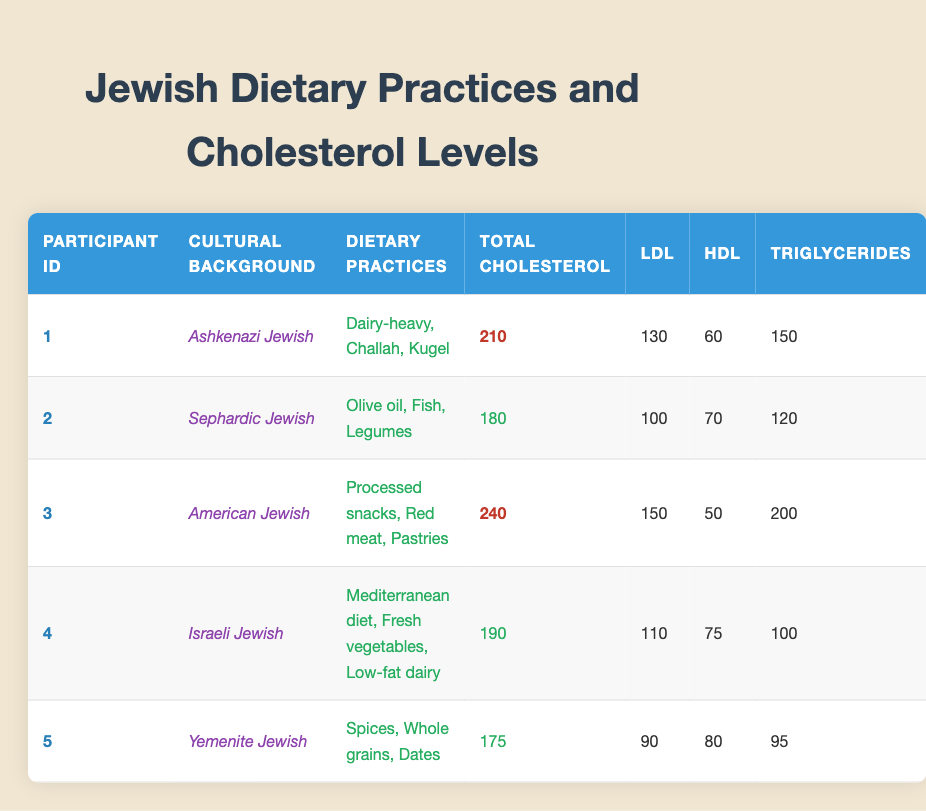What is the Total Cholesterol level of the participant with the highest value? Looking at the Total Cholesterol values in the table, Participant 3 has the highest value of 240.
Answer: 240 Which dietary practices are associated with the lowest LDL level? Participant 5 has the lowest LDL level of 90, and their dietary practices include Spices, Whole grains, and Dates.
Answer: Spices, Whole grains, Dates Is Participant 4's cholesterol level considered high or normal? Participant 4 has a Total Cholesterol level of 190, which according to general health guidelines falls within the normal range (below 200).
Answer: Normal What is the average Total Cholesterol for all participants? To find the average Total Cholesterol, add all Total Cholesterol levels: (210 + 180 + 240 + 190 + 175) = 1095. Then divide by the number of participants (5): 1095/5 = 219.
Answer: 219 How many participants have an HDL level above 70? Checking the HDL levels, Participants 2 (70) and 5 (80) are above or equal to 70, making it a total of 3 participants.
Answer: 3 Which cultural background correlates with the highest Total Cholesterol level? Analyzing the table, Participant 3 with the cultural background "American Jewish" has the highest Total Cholesterol level of 240.
Answer: American Jewish Are there any participants with both normal Total Cholesterol and HDL levels? Participant 2 has a Total Cholesterol of 180 (normal) and an HDL of 70 (normal), so yes, there are participants with both.
Answer: Yes What is the difference in Total Cholesterol between the participant with the highest and the lowest values? The highest Total Cholesterol is 240 (Participant 3) and the lowest is 175 (Participant 5). The difference is 240 - 175 = 65.
Answer: 65 How many participants have cholesterol levels classified as high? The total number of participants with high cholesterol (above 200) are Participants 1 (210) and 3 (240), totaling 2.
Answer: 2 